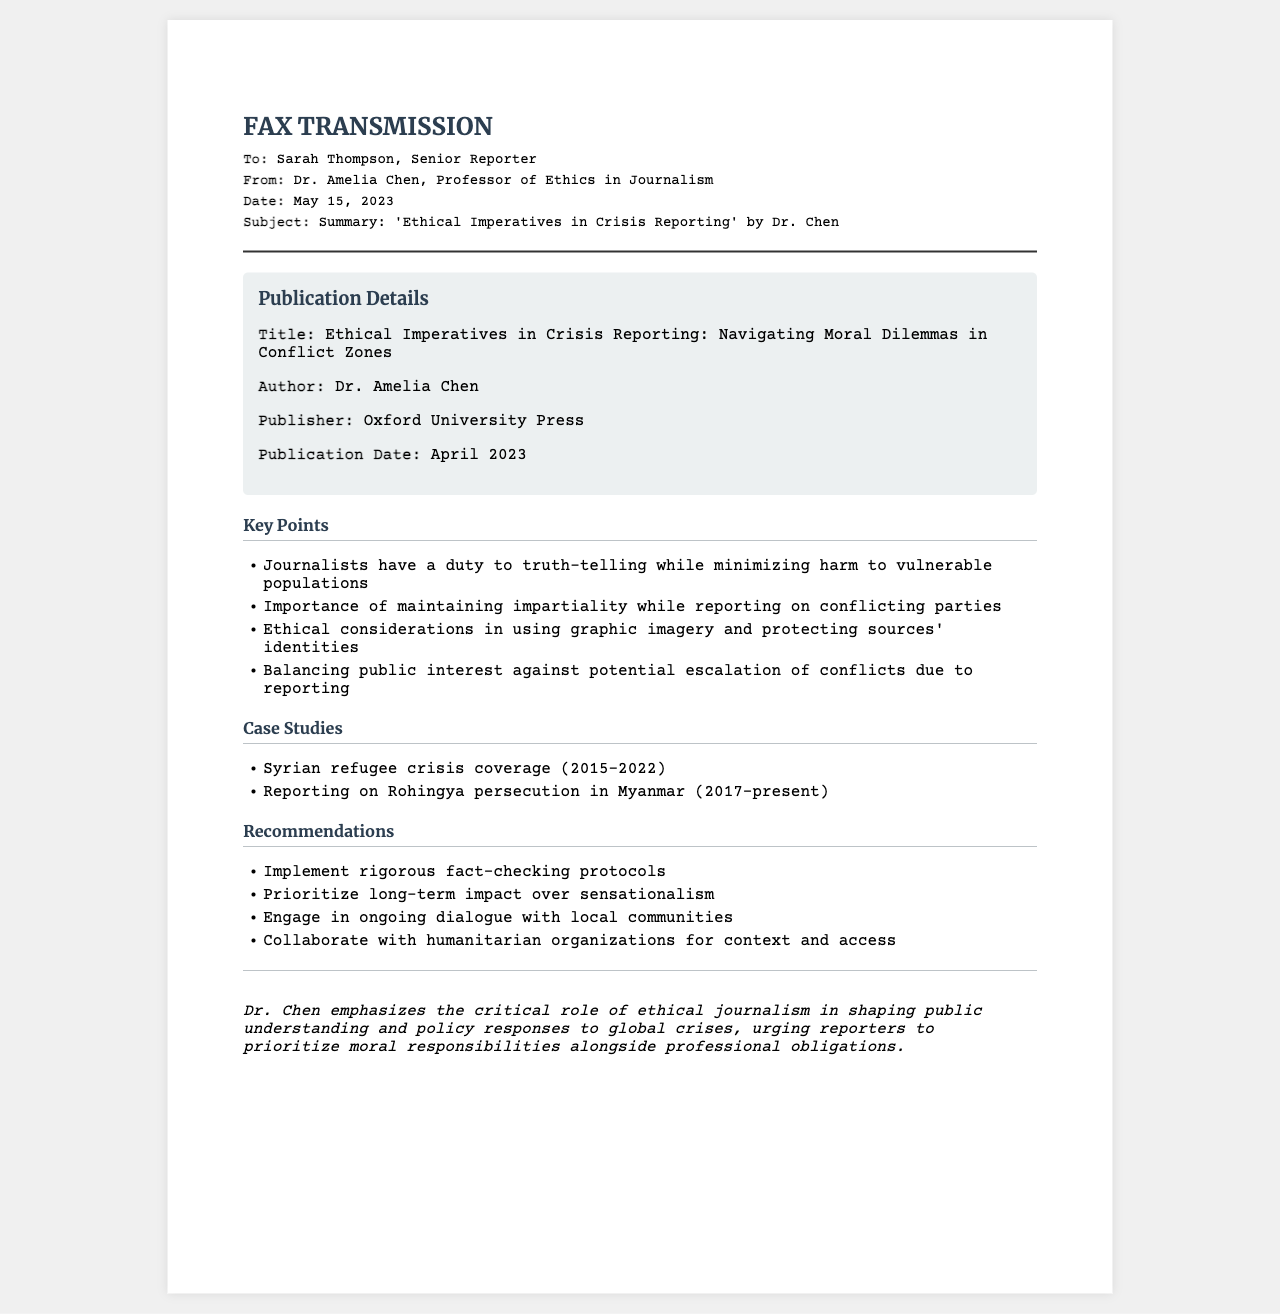What is the title of the publication? The title of the publication is found at the top of the publication details section.
Answer: Ethical Imperatives in Crisis Reporting: Navigating Moral Dilemmas in Conflict Zones Who is the author of the publication? The author of the publication is listed under the publication details section.
Answer: Dr. Amelia Chen When was the publication date? The publication date is specified in the publication details of the document.
Answer: April 2023 What is one of the key responsibilities of journalists mentioned? The document lists key points including the duties of journalists in the key points section.
Answer: Duty to truth-telling Which case study covers the reporting on Rohingya persecution? The case studies section includes specific examples of crisis reporting.
Answer: Reporting on Rohingya persecution in Myanmar (2017-present) What is a recommendation made for journalists? Recommendations for ethical journalism are outlined in their own section.
Answer: Implement rigorous fact-checking protocols How does Dr. Chen suggest reporters should engage with communities? The recommendations emphasize communication with local entities.
Answer: Engage in ongoing dialogue with local communities What type of document is this? The structure and header information specify the nature of the document.
Answer: Fax 